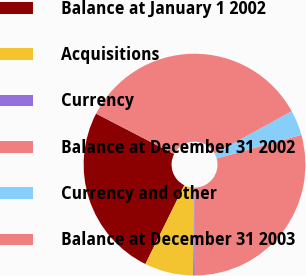<chart> <loc_0><loc_0><loc_500><loc_500><pie_chart><fcel>Balance at January 1 2002<fcel>Acquisitions<fcel>Currency<fcel>Balance at December 31 2002<fcel>Currency and other<fcel>Balance at December 31 2003<nl><fcel>25.31%<fcel>7.09%<fcel>0.26%<fcel>29.28%<fcel>3.68%<fcel>34.39%<nl></chart> 